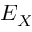Convert formula to latex. <formula><loc_0><loc_0><loc_500><loc_500>E _ { X }</formula> 